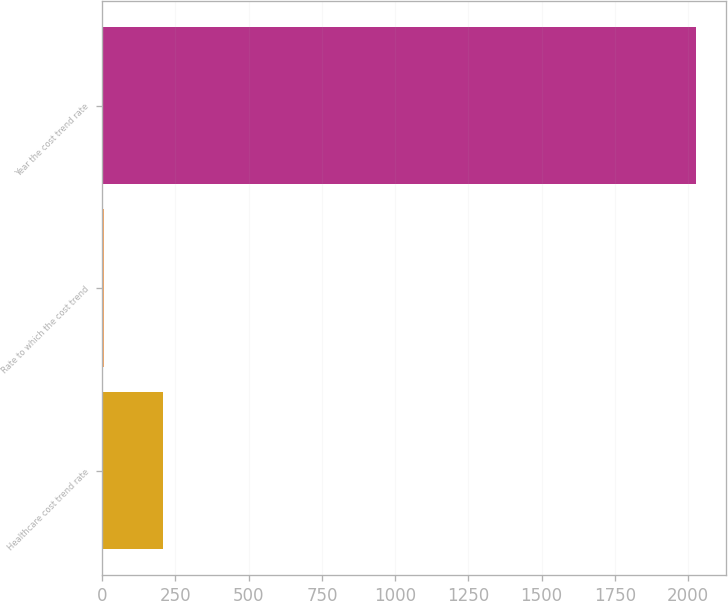Convert chart to OTSL. <chart><loc_0><loc_0><loc_500><loc_500><bar_chart><fcel>Healthcare cost trend rate<fcel>Rate to which the cost trend<fcel>Year the cost trend rate<nl><fcel>206.75<fcel>4.5<fcel>2027<nl></chart> 